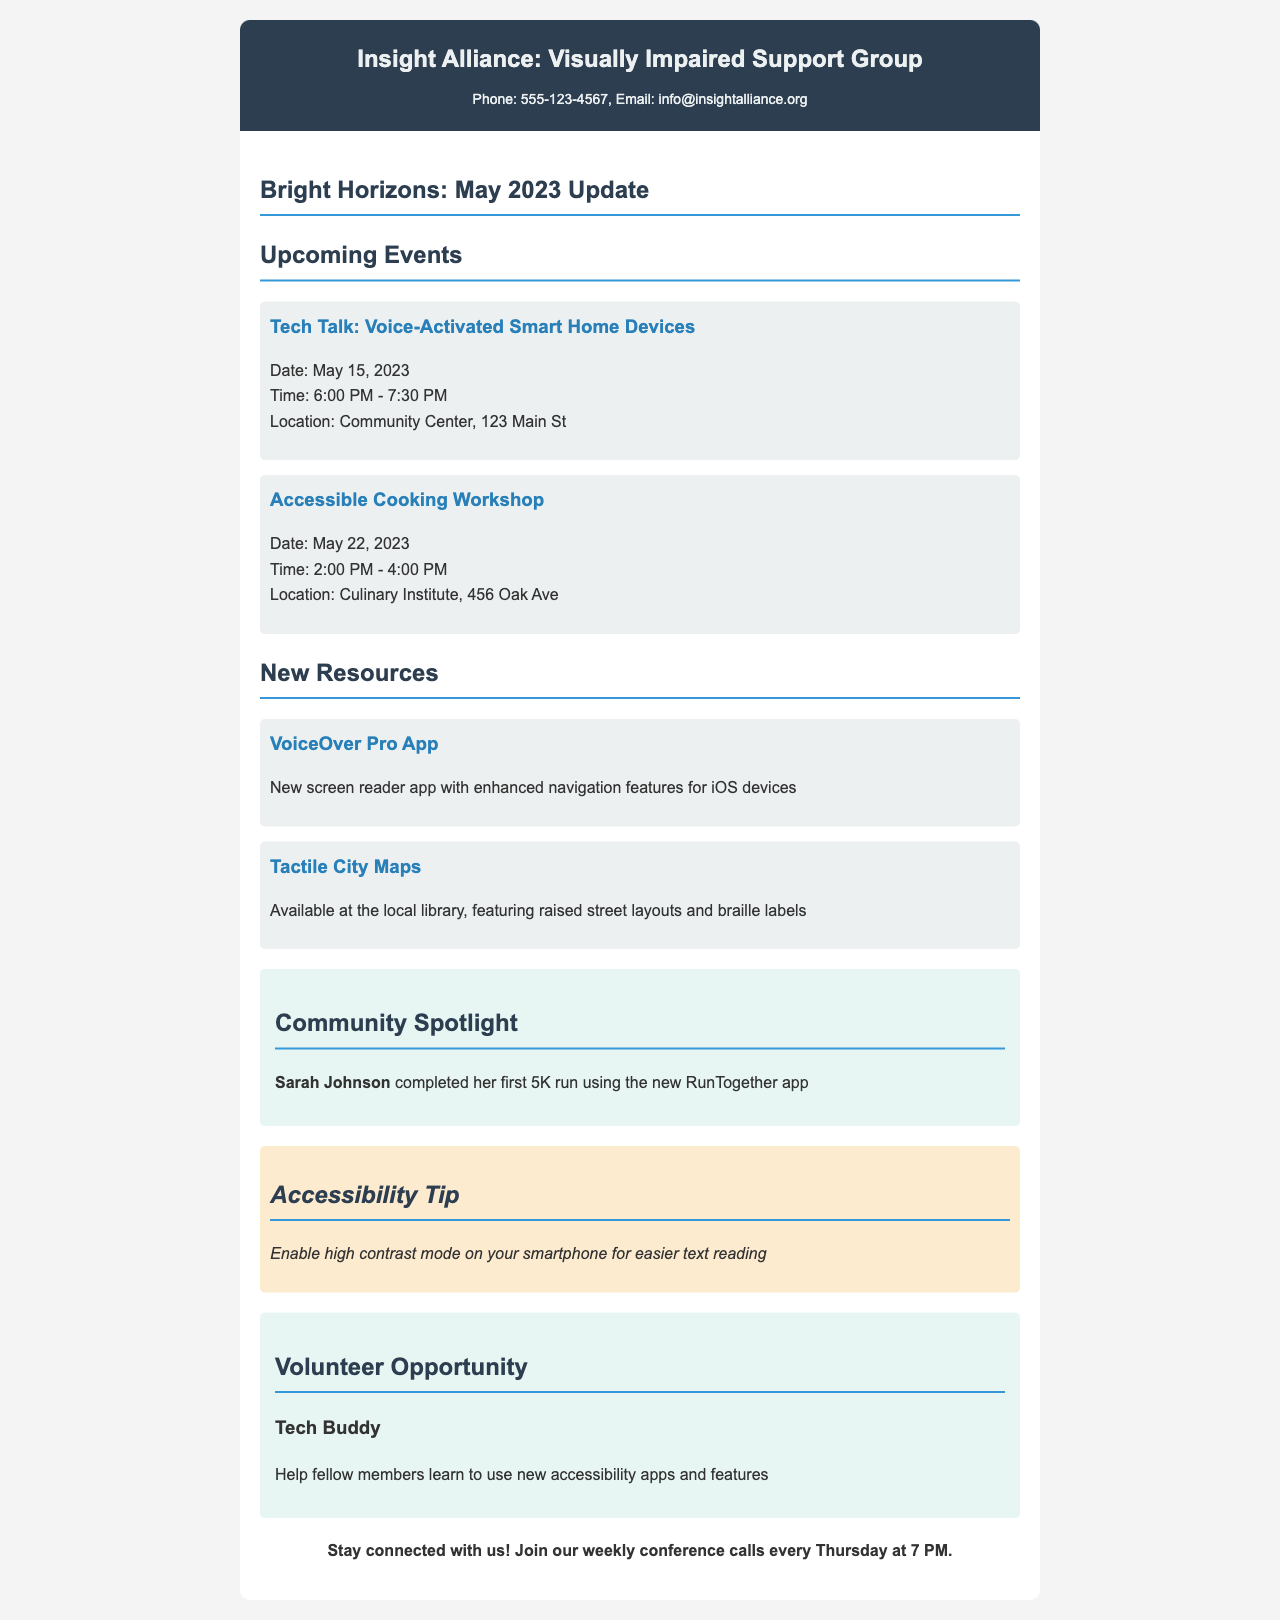What is the title of the newsletter? The title of the newsletter is provided in the header section of the document.
Answer: Insight Alliance: Visually Impaired Support Group What is the date of the Tech Talk event? The date of the Tech Talk event is mentioned in the upcoming events section.
Answer: May 15, 2023 What time does the Accessible Cooking Workshop start? The start time for the Accessible Cooking Workshop is specified in the events section.
Answer: 2:00 PM What is the new app introduced in the resources section? The new app is highlighted in the resources section of the document.
Answer: VoiceOver Pro App Where can Tactile City Maps be found? The location for Tactile City Maps is indicated within the resource information.
Answer: local library Who is highlighted in the Community Spotlight? The individual mentioned in the Community Spotlight section is stated clearly in the document.
Answer: Sarah Johnson What volunteer opportunity is mentioned? The document includes a specific volunteer role under the volunteer section.
Answer: Tech Buddy What day and time do the conference calls occur? The schedule for the weekly conference calls is shared in the closing section of the document.
Answer: Thursdays at 7 PM 